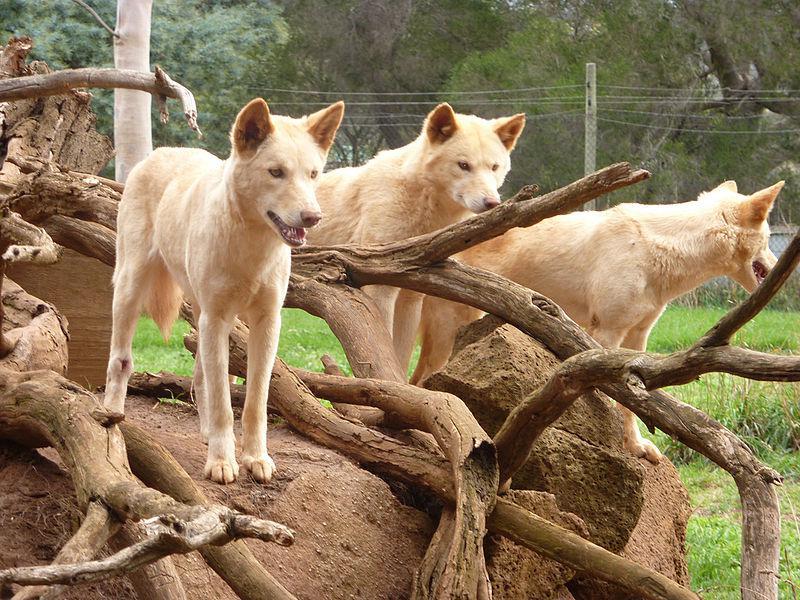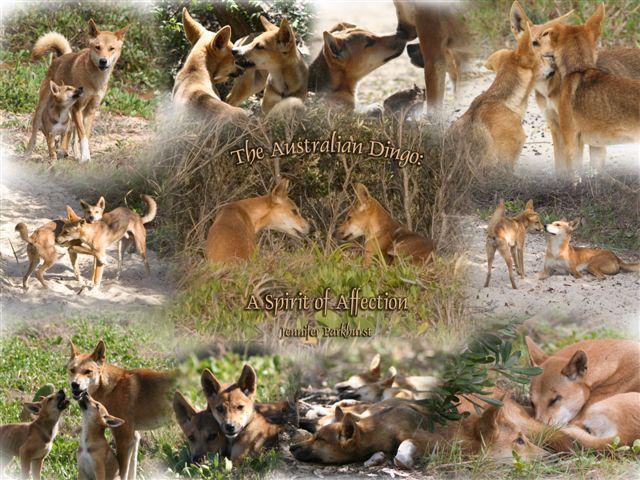The first image is the image on the left, the second image is the image on the right. Considering the images on both sides, is "There are exactly four coyotes." valid? Answer yes or no. No. 